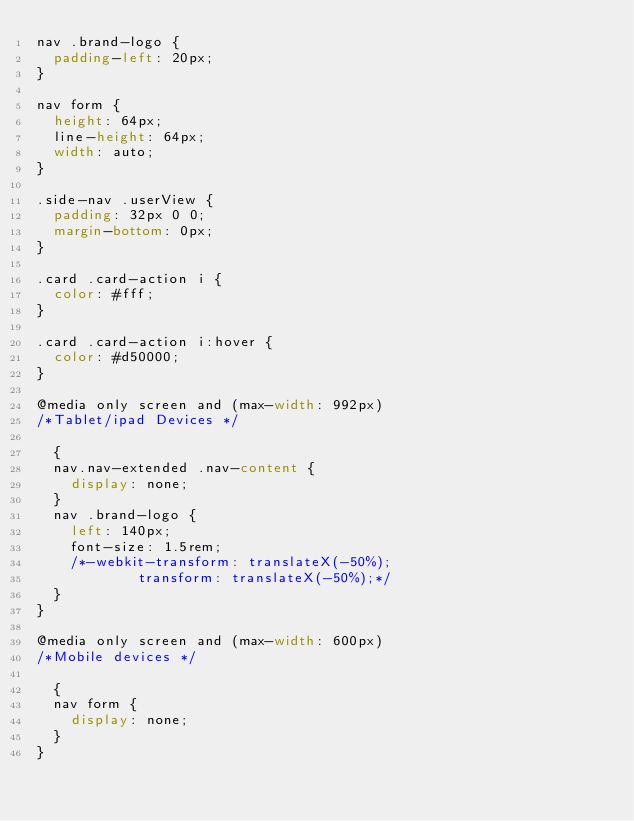Convert code to text. <code><loc_0><loc_0><loc_500><loc_500><_CSS_>nav .brand-logo {
  padding-left: 20px;
}

nav form {
  height: 64px;
  line-height: 64px;
  width: auto;
}

.side-nav .userView {
  padding: 32px 0 0;
  margin-bottom: 0px;
}

.card .card-action i {
  color: #fff;
}

.card .card-action i:hover {
  color: #d50000;
}

@media only screen and (max-width: 992px)
/*Tablet/ipad Devices */

  {
  nav.nav-extended .nav-content {
    display: none;
  }
  nav .brand-logo {
    left: 140px;
    font-size: 1.5rem;
    /*-webkit-transform: translateX(-50%);
            transform: translateX(-50%);*/
  }
}

@media only screen and (max-width: 600px)
/*Mobile devices */

  {
  nav form {
    display: none;
  }
}</code> 